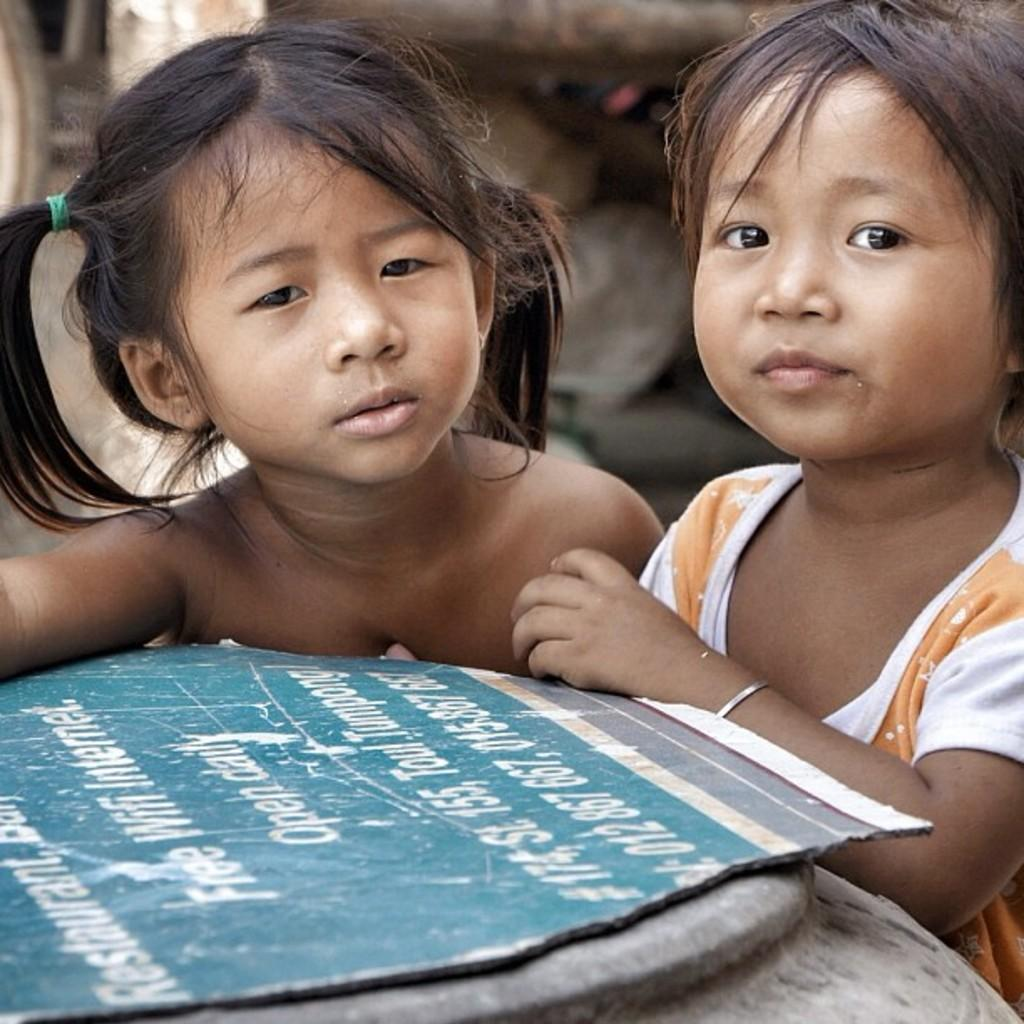How many children are present in the image? There are two children in the image. What is the appearance of the child on the right side? The right side child is wearing clothes. What accessory can be seen in the image? There is a hair band in the image. What object is made of paper in the image? There is a paper sheet in the image. How would you describe the background of the image? The background of the image is blurred. What type of rose is being used as a prop in the image? There is no rose present in the image; it only features two children, a hair band, a paper sheet, and a blurred background. 